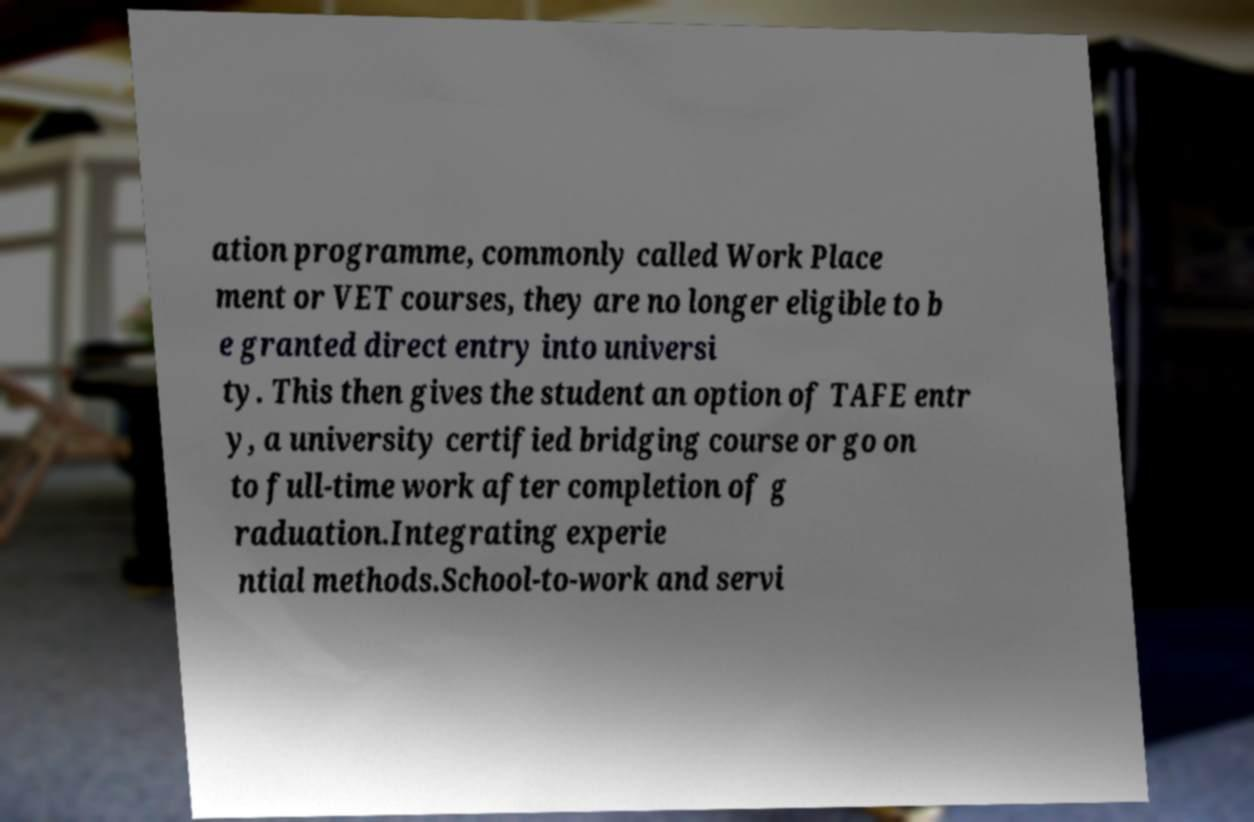Could you extract and type out the text from this image? ation programme, commonly called Work Place ment or VET courses, they are no longer eligible to b e granted direct entry into universi ty. This then gives the student an option of TAFE entr y, a university certified bridging course or go on to full-time work after completion of g raduation.Integrating experie ntial methods.School-to-work and servi 